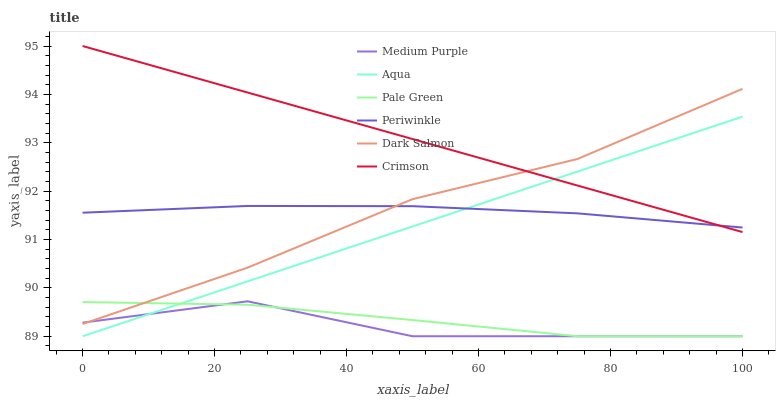Does Medium Purple have the minimum area under the curve?
Answer yes or no. Yes. Does Crimson have the maximum area under the curve?
Answer yes or no. Yes. Does Dark Salmon have the minimum area under the curve?
Answer yes or no. No. Does Dark Salmon have the maximum area under the curve?
Answer yes or no. No. Is Crimson the smoothest?
Answer yes or no. Yes. Is Medium Purple the roughest?
Answer yes or no. Yes. Is Dark Salmon the smoothest?
Answer yes or no. No. Is Dark Salmon the roughest?
Answer yes or no. No. Does Aqua have the lowest value?
Answer yes or no. Yes. Does Dark Salmon have the lowest value?
Answer yes or no. No. Does Crimson have the highest value?
Answer yes or no. Yes. Does Dark Salmon have the highest value?
Answer yes or no. No. Is Pale Green less than Periwinkle?
Answer yes or no. Yes. Is Periwinkle greater than Medium Purple?
Answer yes or no. Yes. Does Medium Purple intersect Pale Green?
Answer yes or no. Yes. Is Medium Purple less than Pale Green?
Answer yes or no. No. Is Medium Purple greater than Pale Green?
Answer yes or no. No. Does Pale Green intersect Periwinkle?
Answer yes or no. No. 